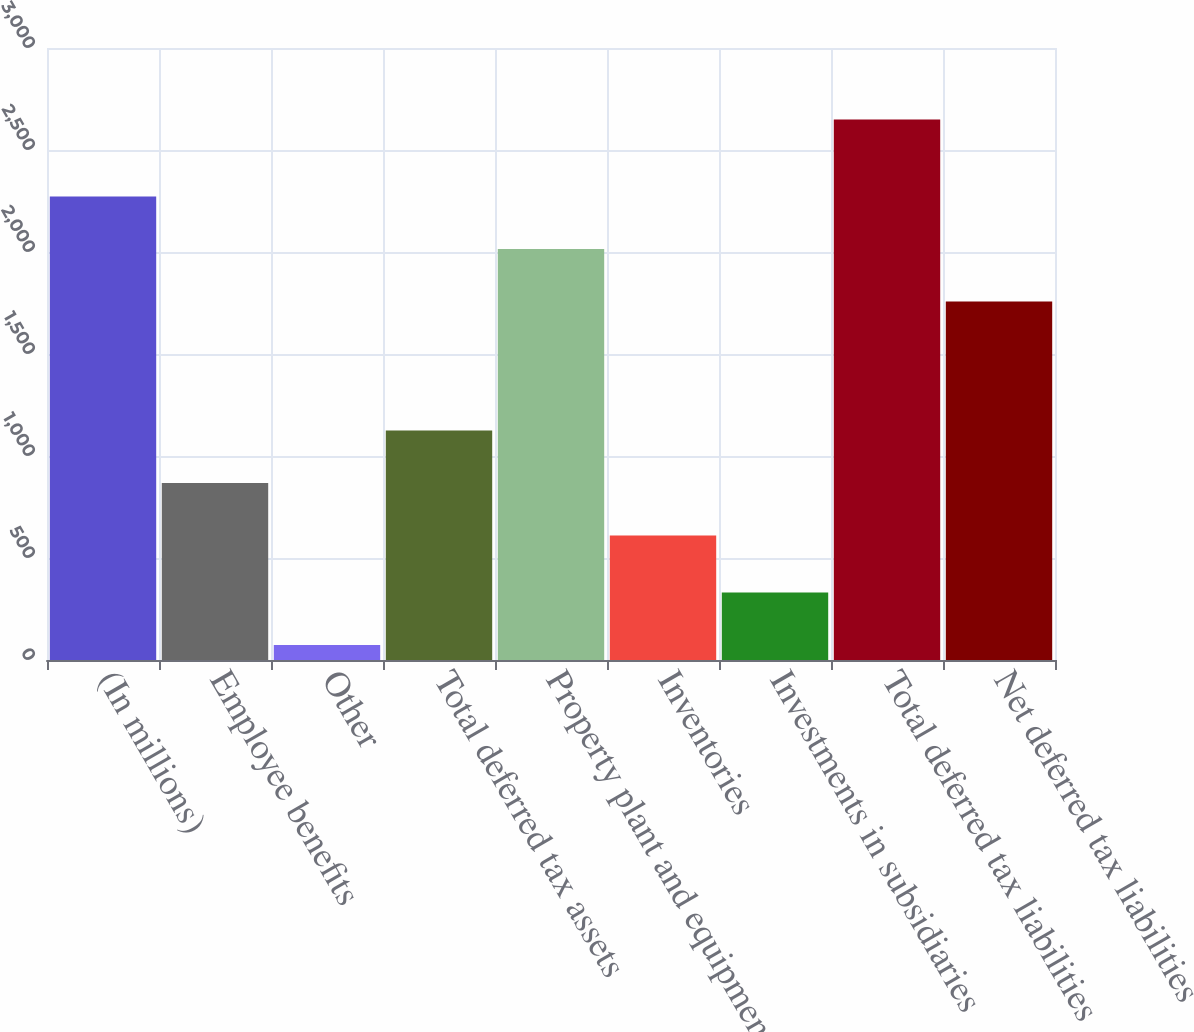<chart> <loc_0><loc_0><loc_500><loc_500><bar_chart><fcel>(In millions)<fcel>Employee benefits<fcel>Other<fcel>Total deferred tax assets<fcel>Property plant and equipment<fcel>Inventories<fcel>Investments in subsidiaries<fcel>Total deferred tax liabilities<fcel>Net deferred tax liabilities<nl><fcel>2272.4<fcel>867.7<fcel>73<fcel>1125.4<fcel>2014.7<fcel>610<fcel>330.7<fcel>2650<fcel>1757<nl></chart> 